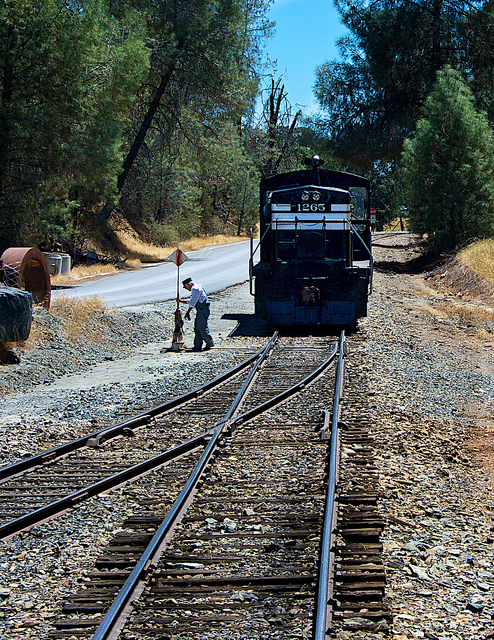What type of transportation is depicted in this image? The image shows a locomotive, which is a type of rail transportation commonly used for both freight and passenger services. 